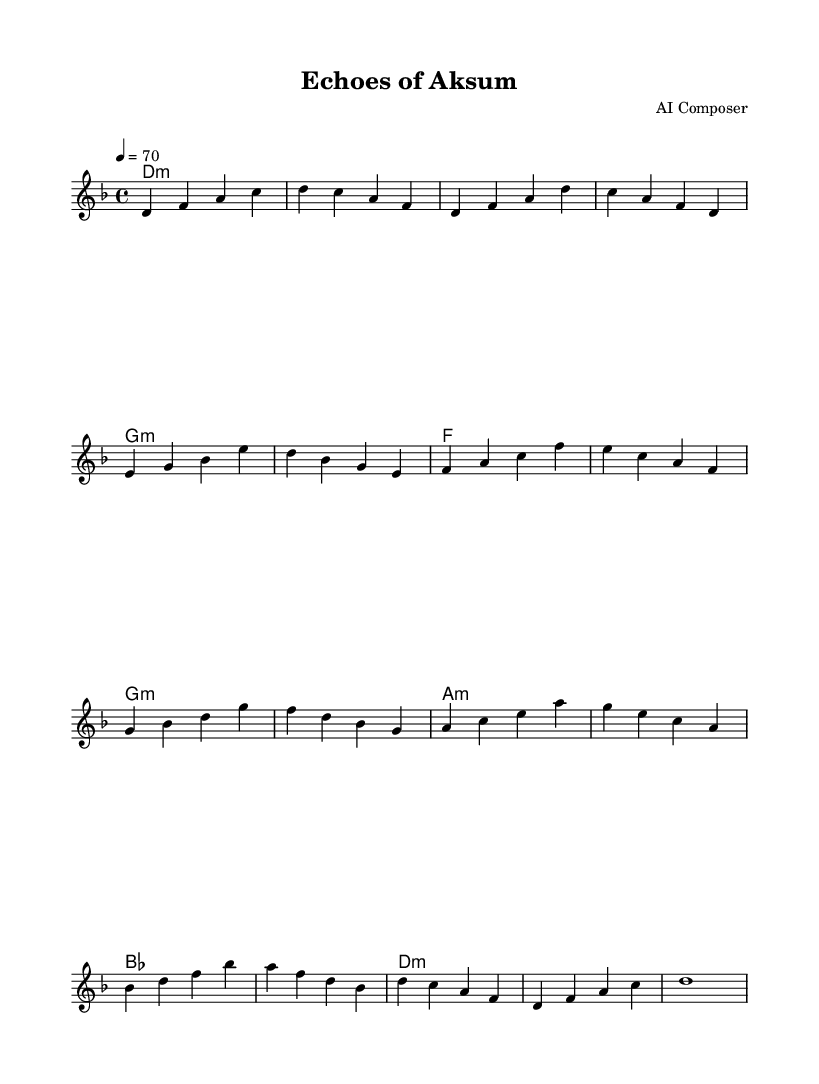What is the key signature of this music? The key signature is D minor, which has one flat (B flat). This can be identified by the key signature indicated at the beginning of the score, showing one flat, confirming it is D minor.
Answer: D minor What is the time signature of this music? The time signature is 4/4, as indicated at the beginning of the score, showing four beats in a measure with a quarter note receiving one beat.
Answer: 4/4 What is the tempo marking of this piece? The tempo marking is 70 beats per minute, specified in the score as "4 = 70". This indicates the speed at which the piece should be performed.
Answer: 70 How many sections does the piece contain? The piece contains five distinct sections: Intro, Verse, Chorus, Bridge, and Outro. Each section is clearly labeled in the melody.
Answer: Five What is the ending chord of the piece? The ending chord is D minor, as indicated by the final harmonies in the score, which shows a D minor chord at the conclusion of the piece.
Answer: D minor Which musical form does this piece follow? The piece follows a strophic form, characterized by repeating the melody in various sections (Verse, Chorus) with slight variations, typical in soundtracks to evoke emotion.
Answer: Strophic What musical mood does this piece evoke? The piece evokes a mysterious and atmospheric mood, typical of electronic scores, reinforced by the use of minor harmonies and flowing melodies that suggest ancient themes.
Answer: Mysterious 